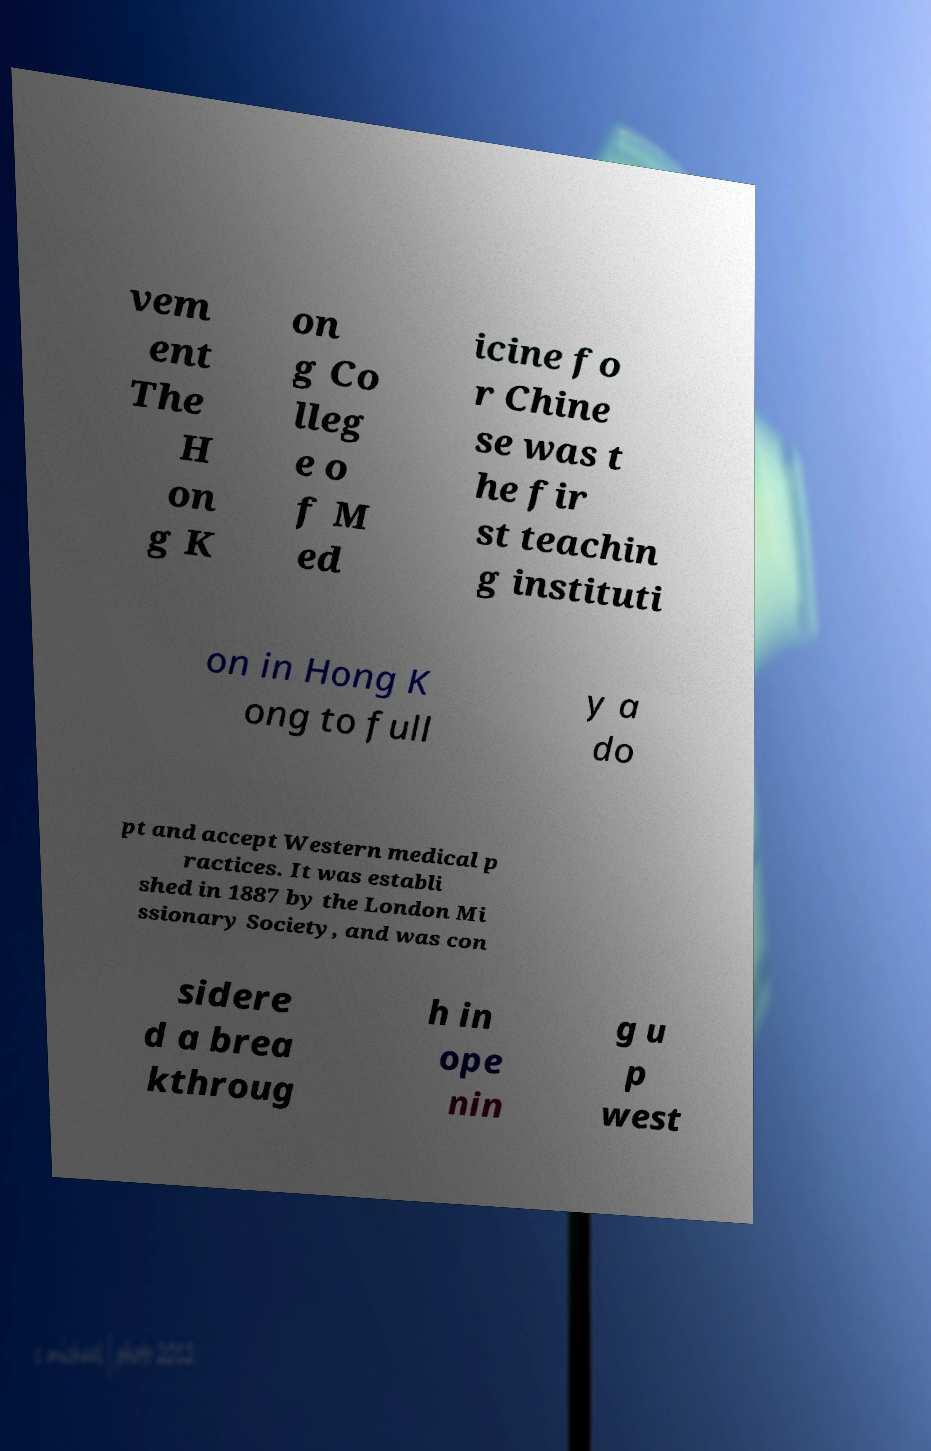What messages or text are displayed in this image? I need them in a readable, typed format. vem ent The H on g K on g Co lleg e o f M ed icine fo r Chine se was t he fir st teachin g instituti on in Hong K ong to full y a do pt and accept Western medical p ractices. It was establi shed in 1887 by the London Mi ssionary Society, and was con sidere d a brea kthroug h in ope nin g u p west 